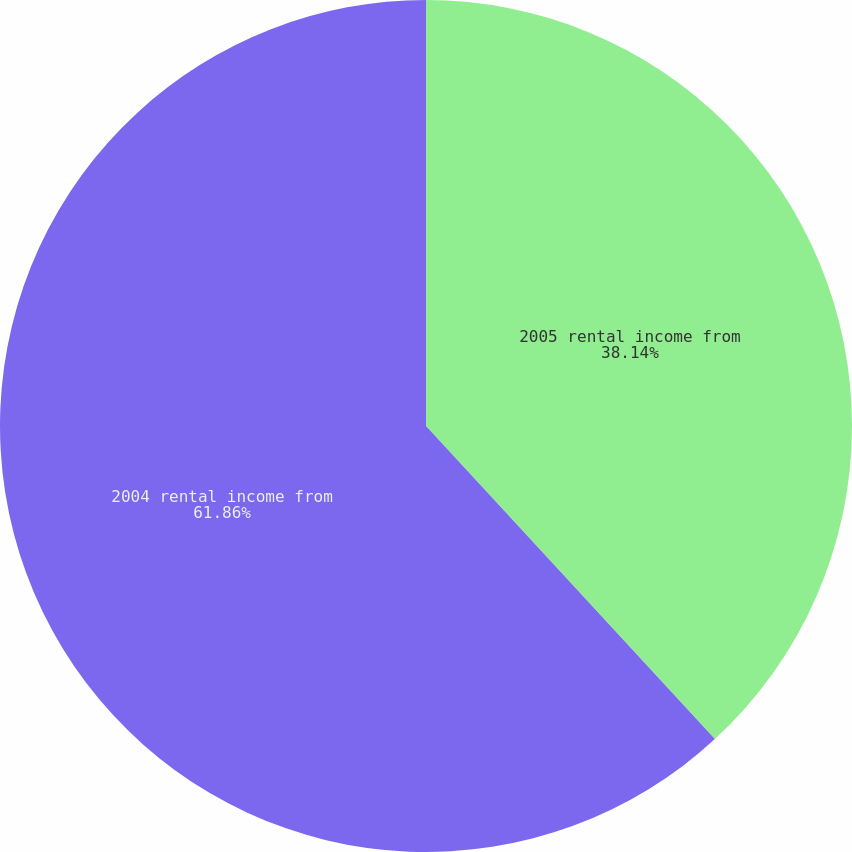Convert chart to OTSL. <chart><loc_0><loc_0><loc_500><loc_500><pie_chart><fcel>2005 rental income from<fcel>2004 rental income from<nl><fcel>38.14%<fcel>61.86%<nl></chart> 